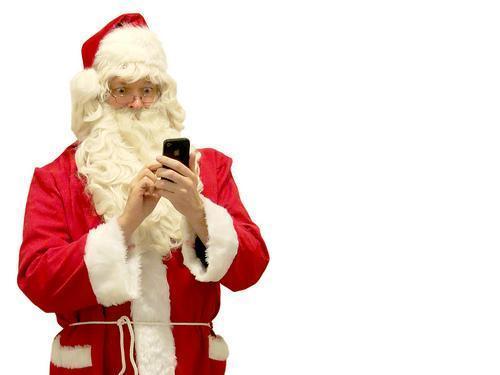How many Santas are in the image?
Give a very brief answer. 1. 